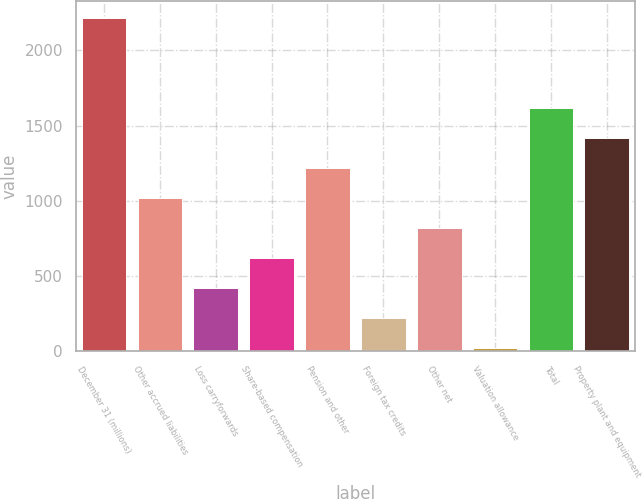Convert chart. <chart><loc_0><loc_0><loc_500><loc_500><bar_chart><fcel>December 31 (millions)<fcel>Other accrued liabilities<fcel>Loss carryforwards<fcel>Share-based compensation<fcel>Pension and other<fcel>Foreign tax credits<fcel>Other net<fcel>Valuation allowance<fcel>Total<fcel>Property plant and equipment<nl><fcel>2215.61<fcel>1017.95<fcel>419.12<fcel>618.73<fcel>1217.56<fcel>219.51<fcel>818.34<fcel>19.9<fcel>1616.78<fcel>1417.17<nl></chart> 